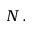Convert formula to latex. <formula><loc_0><loc_0><loc_500><loc_500>N \, .</formula> 